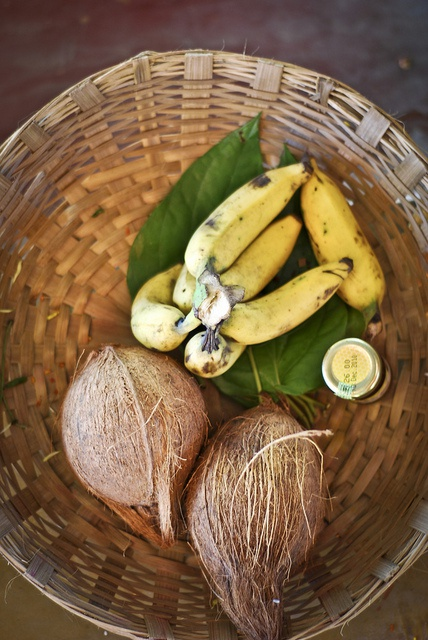Describe the objects in this image and their specific colors. I can see bowl in black, maroon, brown, and gray tones, banana in black, khaki, gold, and beige tones, and banana in black, gold, orange, and olive tones in this image. 